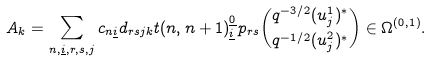<formula> <loc_0><loc_0><loc_500><loc_500>A _ { k } = \sum _ { n , \underline { i } , r , s , j } c _ { n \underline { i } } d _ { r s j k } t ( n , n + 1 ) ^ { \underline { 0 } } _ { \underline { i } } p _ { r s } \binom { q ^ { - 3 / 2 } ( u ^ { 1 } _ { j } ) ^ { * } } { q ^ { - 1 / 2 } ( u ^ { 2 } _ { j } ) ^ { * } } \in \Omega ^ { ( 0 , 1 ) } .</formula> 